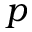<formula> <loc_0><loc_0><loc_500><loc_500>p</formula> 